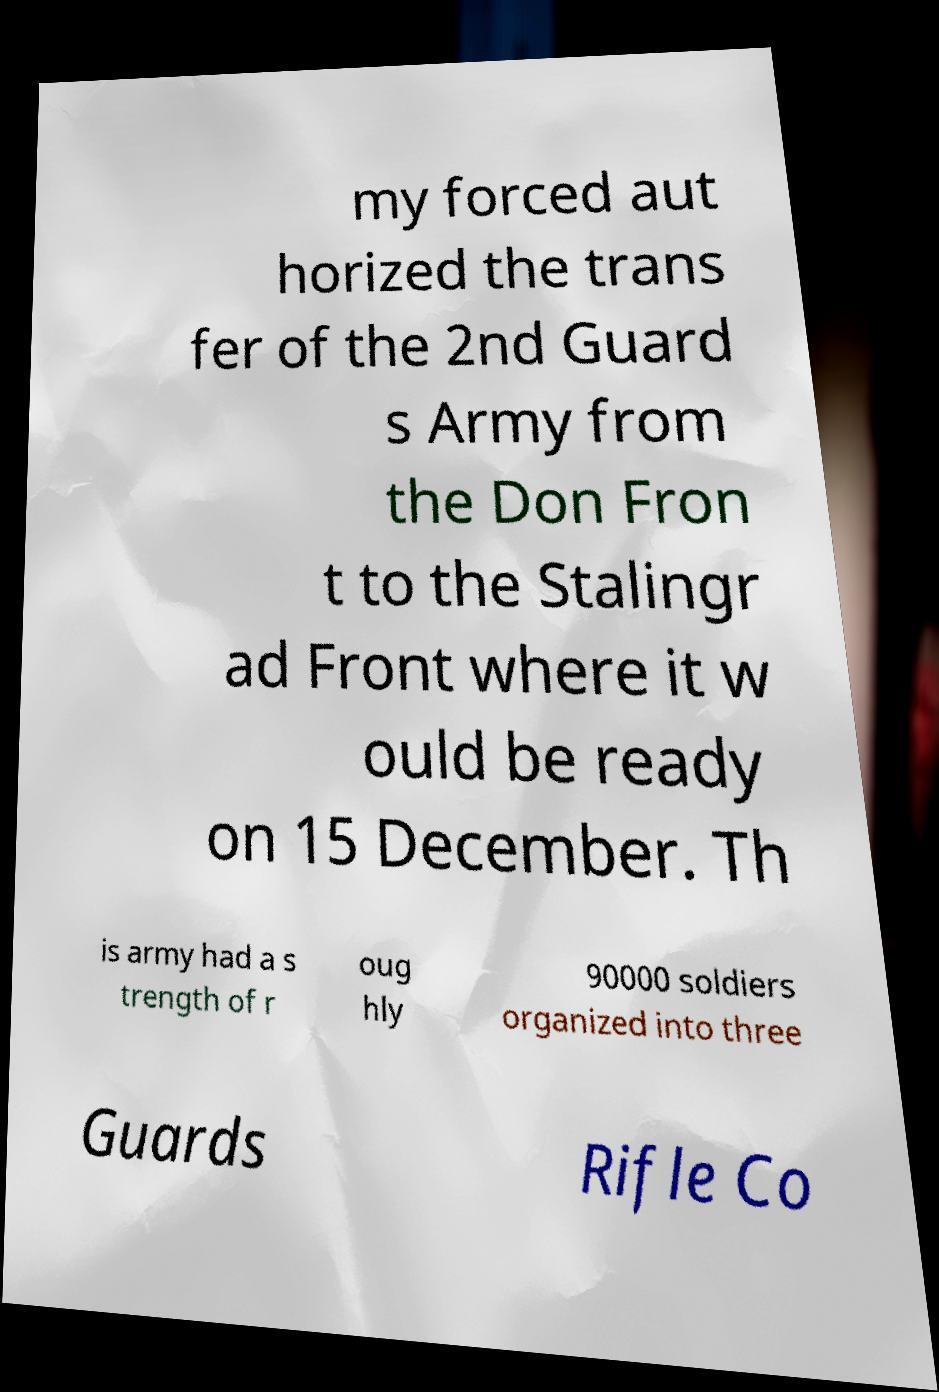There's text embedded in this image that I need extracted. Can you transcribe it verbatim? my forced aut horized the trans fer of the 2nd Guard s Army from the Don Fron t to the Stalingr ad Front where it w ould be ready on 15 December. Th is army had a s trength of r oug hly 90000 soldiers organized into three Guards Rifle Co 